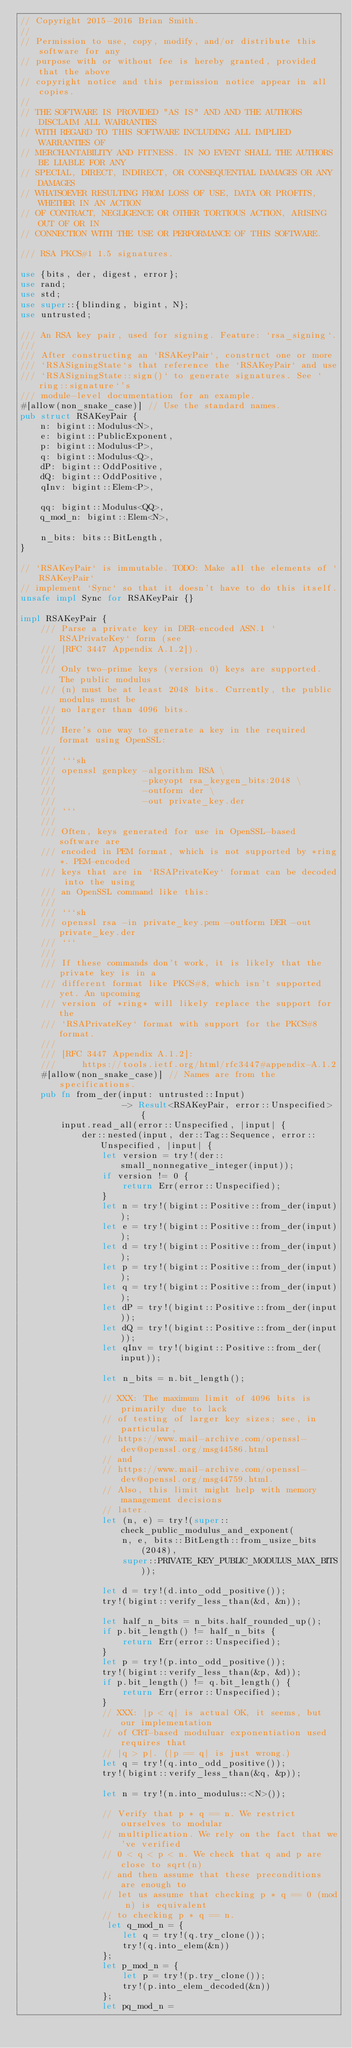Convert code to text. <code><loc_0><loc_0><loc_500><loc_500><_Rust_>// Copyright 2015-2016 Brian Smith.
//
// Permission to use, copy, modify, and/or distribute this software for any
// purpose with or without fee is hereby granted, provided that the above
// copyright notice and this permission notice appear in all copies.
//
// THE SOFTWARE IS PROVIDED "AS IS" AND AND THE AUTHORS DISCLAIM ALL WARRANTIES
// WITH REGARD TO THIS SOFTWARE INCLUDING ALL IMPLIED WARRANTIES OF
// MERCHANTABILITY AND FITNESS. IN NO EVENT SHALL THE AUTHORS BE LIABLE FOR ANY
// SPECIAL, DIRECT, INDIRECT, OR CONSEQUENTIAL DAMAGES OR ANY DAMAGES
// WHATSOEVER RESULTING FROM LOSS OF USE, DATA OR PROFITS, WHETHER IN AN ACTION
// OF CONTRACT, NEGLIGENCE OR OTHER TORTIOUS ACTION, ARISING OUT OF OR IN
// CONNECTION WITH THE USE OR PERFORMANCE OF THIS SOFTWARE.

/// RSA PKCS#1 1.5 signatures.

use {bits, der, digest, error};
use rand;
use std;
use super::{blinding, bigint, N};
use untrusted;

/// An RSA key pair, used for signing. Feature: `rsa_signing`.
///
/// After constructing an `RSAKeyPair`, construct one or more
/// `RSASigningState`s that reference the `RSAKeyPair` and use
/// `RSASigningState::sign()` to generate signatures. See `ring::signature`'s
/// module-level documentation for an example.
#[allow(non_snake_case)] // Use the standard names.
pub struct RSAKeyPair {
    n: bigint::Modulus<N>,
    e: bigint::PublicExponent,
    p: bigint::Modulus<P>,
    q: bigint::Modulus<Q>,
    dP: bigint::OddPositive,
    dQ: bigint::OddPositive,
    qInv: bigint::Elem<P>,

    qq: bigint::Modulus<QQ>,
    q_mod_n: bigint::Elem<N>,

    n_bits: bits::BitLength,
}

// `RSAKeyPair` is immutable. TODO: Make all the elements of `RSAKeyPair`
// implement `Sync` so that it doesn't have to do this itself.
unsafe impl Sync for RSAKeyPair {}

impl RSAKeyPair {
    /// Parse a private key in DER-encoded ASN.1 `RSAPrivateKey` form (see
    /// [RFC 3447 Appendix A.1.2]).
    ///
    /// Only two-prime keys (version 0) keys are supported. The public modulus
    /// (n) must be at least 2048 bits. Currently, the public modulus must be
    /// no larger than 4096 bits.
    ///
    /// Here's one way to generate a key in the required format using OpenSSL:
    ///
    /// ```sh
    /// openssl genpkey -algorithm RSA \
    ///                 -pkeyopt rsa_keygen_bits:2048 \
    ///                 -outform der \
    ///                 -out private_key.der
    /// ```
    ///
    /// Often, keys generated for use in OpenSSL-based software are
    /// encoded in PEM format, which is not supported by *ring*. PEM-encoded
    /// keys that are in `RSAPrivateKey` format can be decoded into the using
    /// an OpenSSL command like this:
    ///
    /// ```sh
    /// openssl rsa -in private_key.pem -outform DER -out private_key.der
    /// ```
    ///
    /// If these commands don't work, it is likely that the private key is in a
    /// different format like PKCS#8, which isn't supported yet. An upcoming
    /// version of *ring* will likely replace the support for the
    /// `RSAPrivateKey` format with support for the PKCS#8 format.
    ///
    /// [RFC 3447 Appendix A.1.2]:
    ///     https://tools.ietf.org/html/rfc3447#appendix-A.1.2
    #[allow(non_snake_case)] // Names are from the specifications.
    pub fn from_der(input: untrusted::Input)
                    -> Result<RSAKeyPair, error::Unspecified> {
        input.read_all(error::Unspecified, |input| {
            der::nested(input, der::Tag::Sequence, error::Unspecified, |input| {
                let version = try!(der::small_nonnegative_integer(input));
                if version != 0 {
                    return Err(error::Unspecified);
                }
                let n = try!(bigint::Positive::from_der(input));
                let e = try!(bigint::Positive::from_der(input));
                let d = try!(bigint::Positive::from_der(input));
                let p = try!(bigint::Positive::from_der(input));
                let q = try!(bigint::Positive::from_der(input));
                let dP = try!(bigint::Positive::from_der(input));
                let dQ = try!(bigint::Positive::from_der(input));
                let qInv = try!(bigint::Positive::from_der(input));

                let n_bits = n.bit_length();

                // XXX: The maximum limit of 4096 bits is primarily due to lack
                // of testing of larger key sizes; see, in particular,
                // https://www.mail-archive.com/openssl-dev@openssl.org/msg44586.html
                // and
                // https://www.mail-archive.com/openssl-dev@openssl.org/msg44759.html.
                // Also, this limit might help with memory management decisions
                // later.
                let (n, e) = try!(super::check_public_modulus_and_exponent(
                    n, e, bits::BitLength::from_usize_bits(2048),
                    super::PRIVATE_KEY_PUBLIC_MODULUS_MAX_BITS));

                let d = try!(d.into_odd_positive());
                try!(bigint::verify_less_than(&d, &n));

                let half_n_bits = n_bits.half_rounded_up();
                if p.bit_length() != half_n_bits {
                    return Err(error::Unspecified);
                }
                let p = try!(p.into_odd_positive());
                try!(bigint::verify_less_than(&p, &d));
                if p.bit_length() != q.bit_length() {
                    return Err(error::Unspecified);
                }
                // XXX: |p < q| is actual OK, it seems, but our implementation
                // of CRT-based moduluar exponentiation used requires that
                // |q > p|. (|p == q| is just wrong.)
                let q = try!(q.into_odd_positive());
                try!(bigint::verify_less_than(&q, &p));

                let n = try!(n.into_modulus::<N>());

                // Verify that p * q == n. We restrict ourselves to modular
                // multiplication. We rely on the fact that we've verified
                // 0 < q < p < n. We check that q and p are close to sqrt(n)
                // and then assume that these preconditions are enough to
                // let us assume that checking p * q == 0 (mod n) is equivalent
                // to checking p * q == n.
                 let q_mod_n = {
                    let q = try!(q.try_clone());
                    try!(q.into_elem(&n))
                };
                let p_mod_n = {
                    let p = try!(p.try_clone());
                    try!(p.into_elem_decoded(&n))
                };
                let pq_mod_n =</code> 